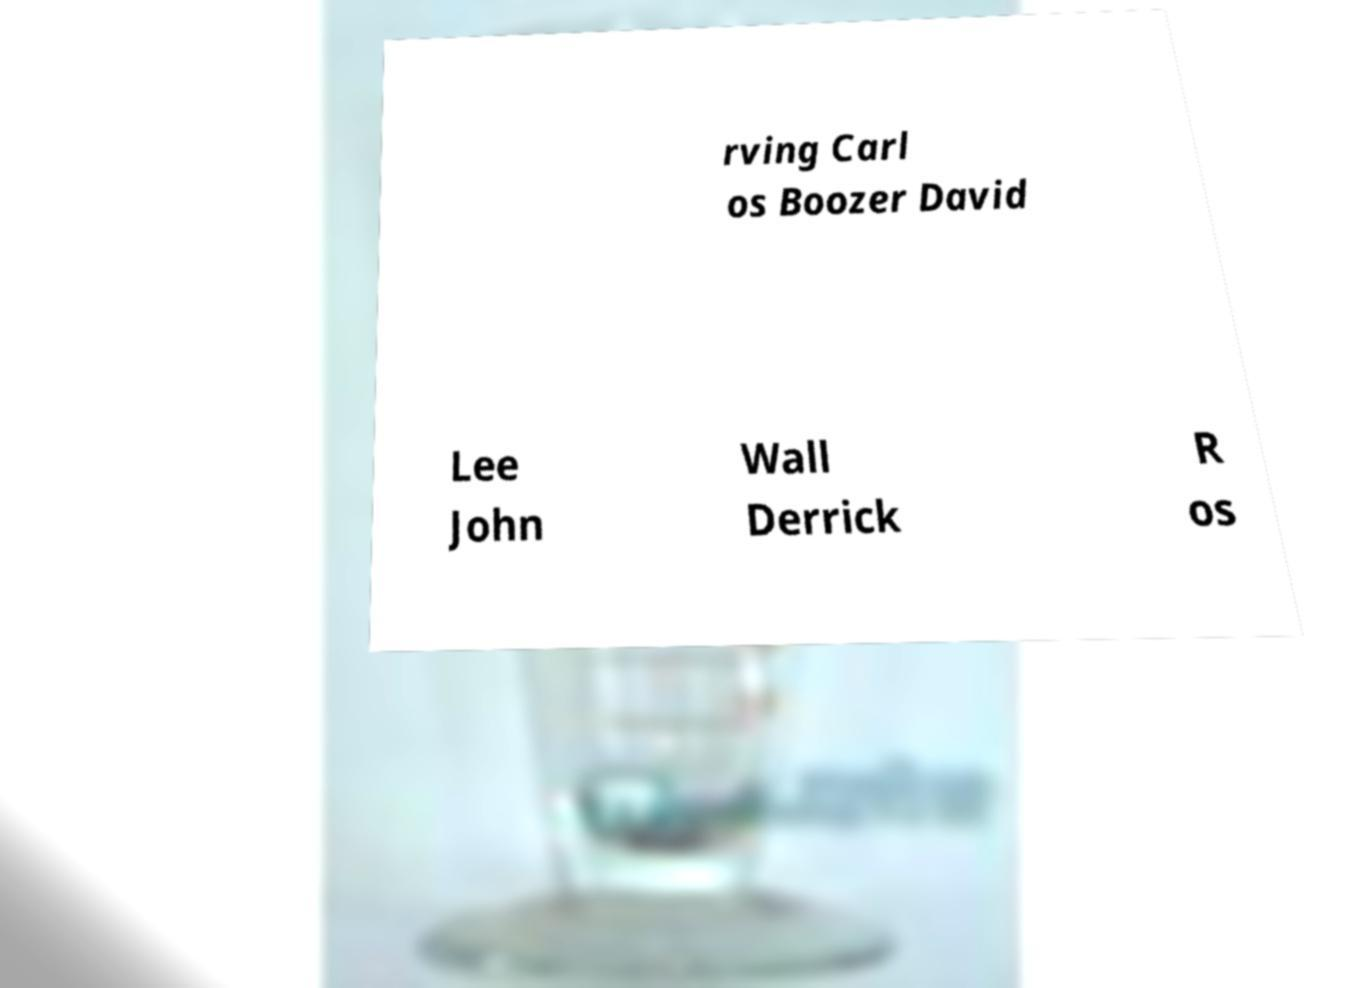Can you read and provide the text displayed in the image?This photo seems to have some interesting text. Can you extract and type it out for me? rving Carl os Boozer David Lee John Wall Derrick R os 